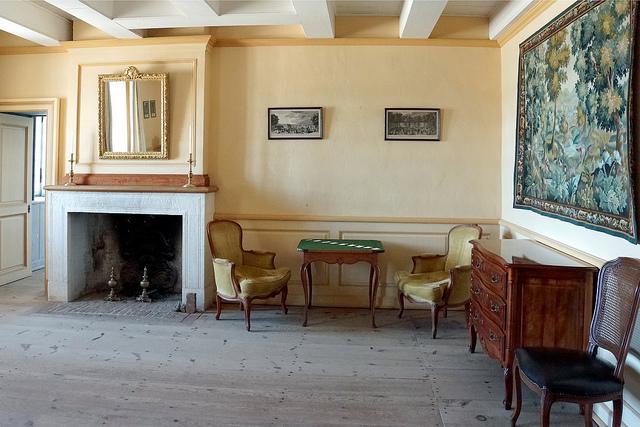Is a fire burning in the fireplace?
Keep it brief. No. How many chairs are in the room?
Answer briefly. 3. Is the door to the other room open?
Concise answer only. Yes. 